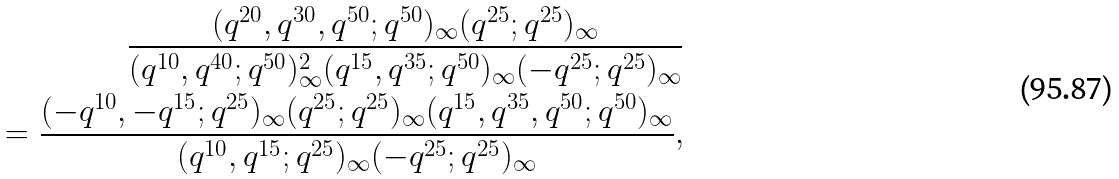Convert formula to latex. <formula><loc_0><loc_0><loc_500><loc_500>\frac { ( q ^ { 2 0 } , q ^ { 3 0 } , q ^ { 5 0 } ; q ^ { 5 0 } ) _ { \infty } ( q ^ { 2 5 } ; q ^ { 2 5 } ) _ { \infty } } { ( q ^ { 1 0 } , q ^ { 4 0 } ; q ^ { 5 0 } ) _ { \infty } ^ { 2 } ( q ^ { 1 5 } , q ^ { 3 5 } ; q ^ { 5 0 } ) _ { \infty } ( - q ^ { 2 5 } ; q ^ { 2 5 } ) _ { \infty } } \\ = \frac { ( - q ^ { 1 0 } , - q ^ { 1 5 } ; q ^ { 2 5 } ) _ { \infty } ( q ^ { 2 5 } ; q ^ { 2 5 } ) _ { \infty } ( q ^ { 1 5 } , q ^ { 3 5 } , q ^ { 5 0 } ; q ^ { 5 0 } ) _ { \infty } } { ( q ^ { 1 0 } , q ^ { 1 5 } ; q ^ { 2 5 } ) _ { \infty } ( - q ^ { 2 5 } ; q ^ { 2 5 } ) _ { \infty } } ,</formula> 